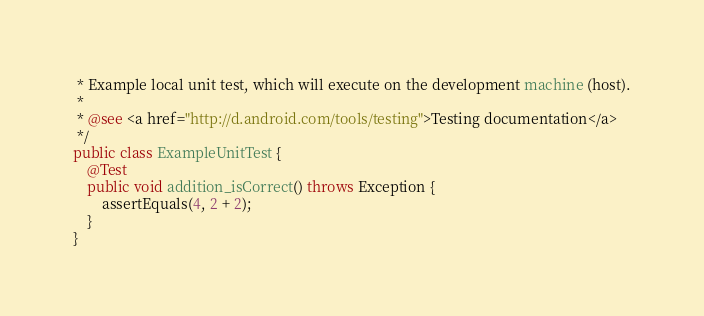Convert code to text. <code><loc_0><loc_0><loc_500><loc_500><_Java_> * Example local unit test, which will execute on the development machine (host).
 *
 * @see <a href="http://d.android.com/tools/testing">Testing documentation</a>
 */
public class ExampleUnitTest {
    @Test
    public void addition_isCorrect() throws Exception {
        assertEquals(4, 2 + 2);
    }
}</code> 